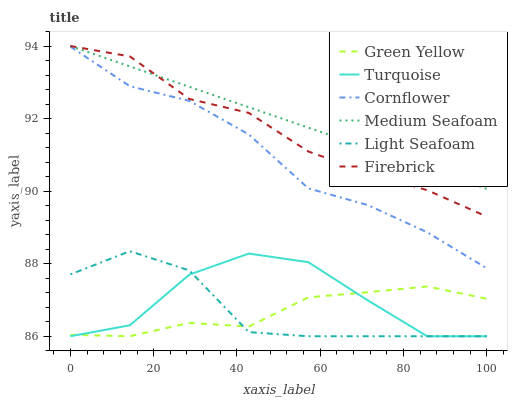Does Green Yellow have the minimum area under the curve?
Answer yes or no. Yes. Does Medium Seafoam have the maximum area under the curve?
Answer yes or no. Yes. Does Turquoise have the minimum area under the curve?
Answer yes or no. No. Does Turquoise have the maximum area under the curve?
Answer yes or no. No. Is Medium Seafoam the smoothest?
Answer yes or no. Yes. Is Turquoise the roughest?
Answer yes or no. Yes. Is Light Seafoam the smoothest?
Answer yes or no. No. Is Light Seafoam the roughest?
Answer yes or no. No. Does Firebrick have the lowest value?
Answer yes or no. No. Does Turquoise have the highest value?
Answer yes or no. No. Is Green Yellow less than Firebrick?
Answer yes or no. Yes. Is Cornflower greater than Turquoise?
Answer yes or no. Yes. Does Green Yellow intersect Firebrick?
Answer yes or no. No. 